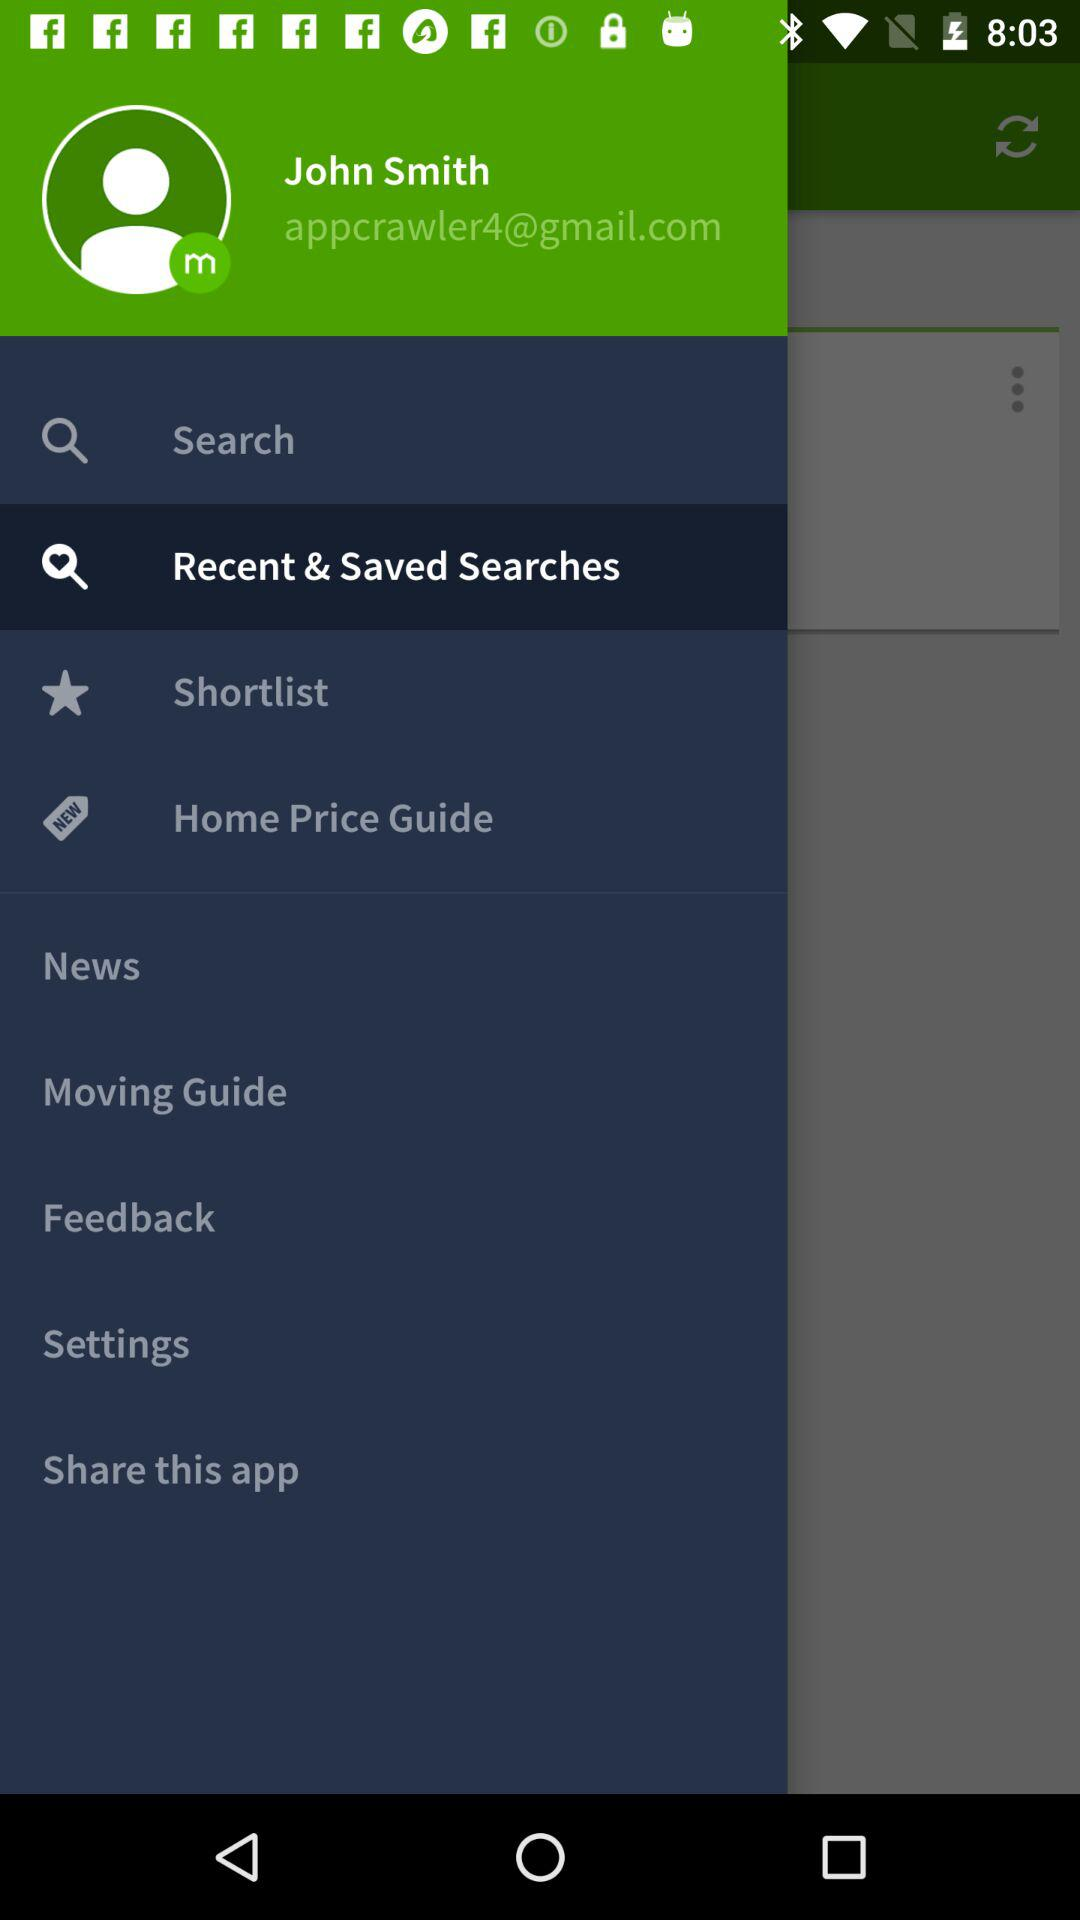What is the Gmail account? The Gmail account is appcrawler4@gmail.com. 